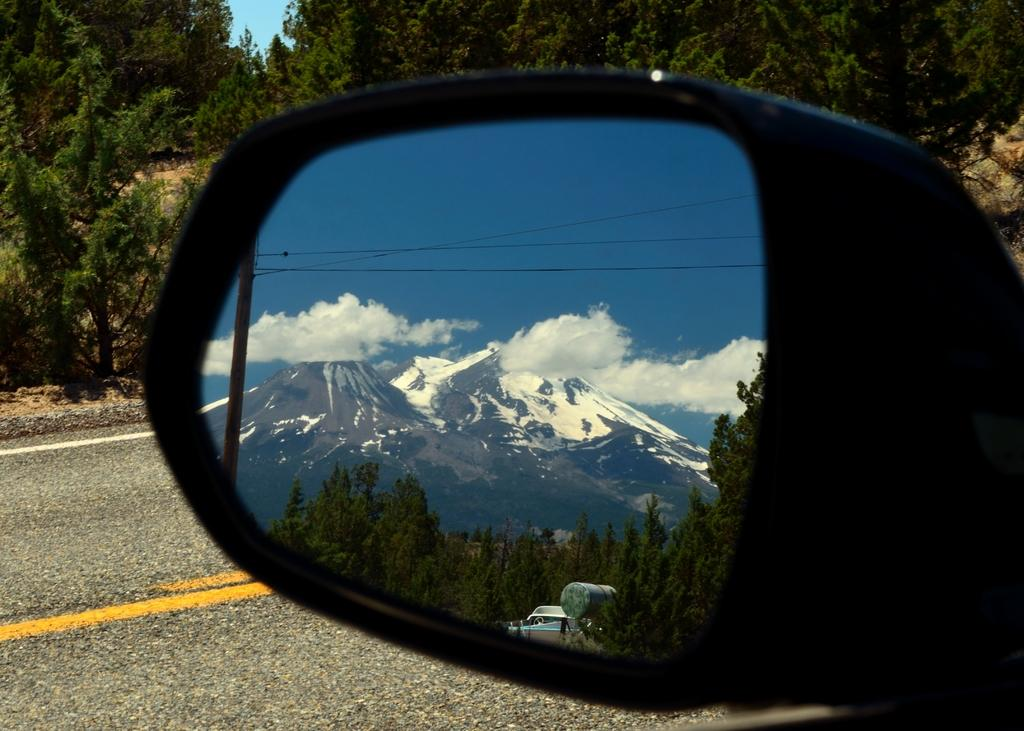What object in the image reflects the surrounding environment? There is a mirror in the image that reflects the surrounding environment. What natural features can be seen in the mirror? Mountains, trees, and the sky are visible in the mirror. What man-made structures can be seen in the mirror? A pole with wires is visible in the mirror. What is the condition of the road in the image? There is a road in the image, and lines on the road are visible. What day of the week is it in the image? The day of the week is not visible or mentioned in the image. Can you hear anyone laughing in the image? There is no sound or indication of laughter in the image. 